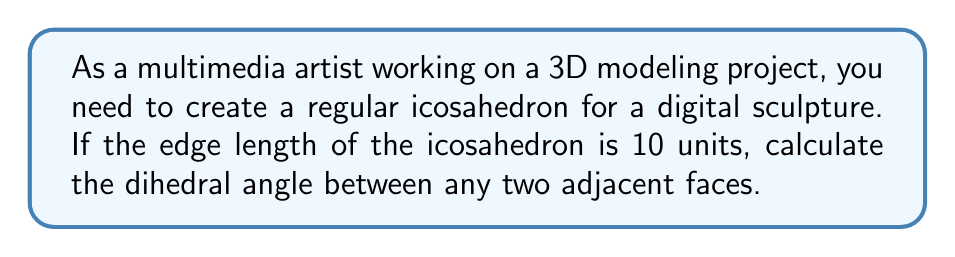Can you solve this math problem? To solve this problem, we'll follow these steps:

1) First, recall that a dihedral angle is the angle between two intersecting planes.

2) For a regular icosahedron, all dihedral angles are equal. The formula for the dihedral angle $\theta$ of a regular icosahedron is:

   $$\theta = \arccos\left(-\frac{1}{\sqrt{5}}\right)$$

3) This formula is independent of the edge length, so we don't need to use the given edge length of 10 units.

4) Let's calculate:

   $$\theta = \arccos\left(-\frac{1}{\sqrt{5}}\right)$$

5) $\sqrt{5} \approx 2.236$

6) $-\frac{1}{\sqrt{5}} \approx -0.4472$

7) $\arccos(-0.4472) \approx 2.0344$ radians

8) Convert to degrees:
   
   $$2.0344 \times \frac{180}{\pi} \approx 138.19°$$

Therefore, the dihedral angle between any two adjacent faces of the regular icosahedron is approximately 138.19°.
Answer: $138.19°$ 